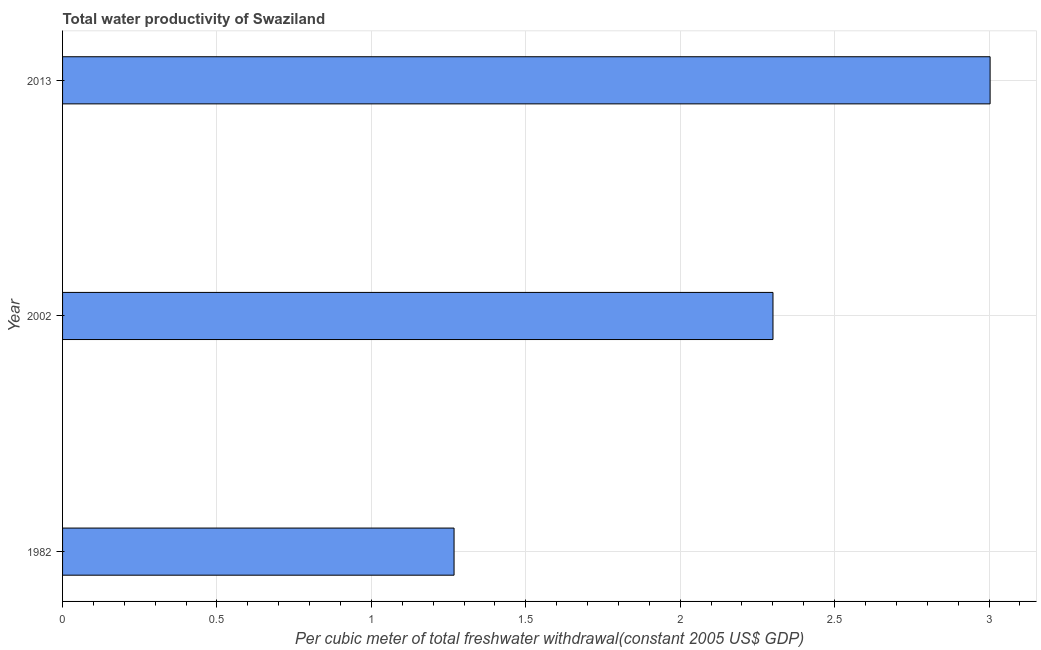Does the graph contain any zero values?
Ensure brevity in your answer.  No. What is the title of the graph?
Provide a succinct answer. Total water productivity of Swaziland. What is the label or title of the X-axis?
Offer a terse response. Per cubic meter of total freshwater withdrawal(constant 2005 US$ GDP). What is the total water productivity in 2013?
Keep it short and to the point. 3. Across all years, what is the maximum total water productivity?
Your answer should be compact. 3. Across all years, what is the minimum total water productivity?
Make the answer very short. 1.27. What is the sum of the total water productivity?
Your answer should be very brief. 6.57. What is the difference between the total water productivity in 2002 and 2013?
Give a very brief answer. -0.7. What is the average total water productivity per year?
Give a very brief answer. 2.19. What is the median total water productivity?
Ensure brevity in your answer.  2.3. What is the ratio of the total water productivity in 1982 to that in 2013?
Provide a short and direct response. 0.42. What is the difference between the highest and the second highest total water productivity?
Offer a terse response. 0.7. Is the sum of the total water productivity in 1982 and 2013 greater than the maximum total water productivity across all years?
Offer a terse response. Yes. What is the difference between the highest and the lowest total water productivity?
Make the answer very short. 1.74. What is the difference between two consecutive major ticks on the X-axis?
Make the answer very short. 0.5. What is the Per cubic meter of total freshwater withdrawal(constant 2005 US$ GDP) of 1982?
Make the answer very short. 1.27. What is the Per cubic meter of total freshwater withdrawal(constant 2005 US$ GDP) of 2002?
Offer a very short reply. 2.3. What is the Per cubic meter of total freshwater withdrawal(constant 2005 US$ GDP) of 2013?
Your answer should be compact. 3. What is the difference between the Per cubic meter of total freshwater withdrawal(constant 2005 US$ GDP) in 1982 and 2002?
Your answer should be compact. -1.03. What is the difference between the Per cubic meter of total freshwater withdrawal(constant 2005 US$ GDP) in 1982 and 2013?
Offer a terse response. -1.74. What is the difference between the Per cubic meter of total freshwater withdrawal(constant 2005 US$ GDP) in 2002 and 2013?
Provide a succinct answer. -0.7. What is the ratio of the Per cubic meter of total freshwater withdrawal(constant 2005 US$ GDP) in 1982 to that in 2002?
Give a very brief answer. 0.55. What is the ratio of the Per cubic meter of total freshwater withdrawal(constant 2005 US$ GDP) in 1982 to that in 2013?
Ensure brevity in your answer.  0.42. What is the ratio of the Per cubic meter of total freshwater withdrawal(constant 2005 US$ GDP) in 2002 to that in 2013?
Your response must be concise. 0.77. 